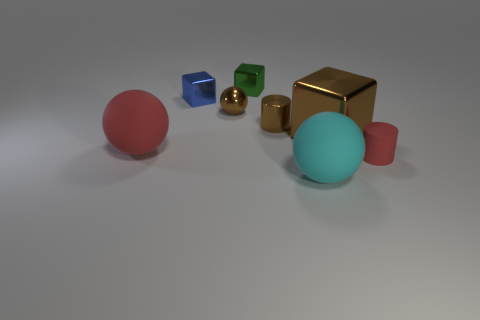The small object that is in front of the red matte sphere has what shape?
Your answer should be very brief. Cylinder. Do the green block and the blue thing have the same material?
Your answer should be very brief. Yes. Is there anything else that is made of the same material as the tiny brown cylinder?
Provide a succinct answer. Yes. There is a tiny brown thing that is the same shape as the tiny red thing; what is its material?
Provide a short and direct response. Metal. Is the number of rubber cylinders that are to the left of the small red rubber object less than the number of brown metal cylinders?
Make the answer very short. Yes. How many shiny objects are behind the shiny cylinder?
Your answer should be compact. 3. Do the big rubber thing that is in front of the tiny rubber cylinder and the rubber thing to the left of the tiny blue metallic block have the same shape?
Ensure brevity in your answer.  Yes. There is a matte thing that is left of the matte cylinder and right of the blue cube; what is its shape?
Ensure brevity in your answer.  Sphere. There is a brown block that is the same material as the small brown ball; what is its size?
Your answer should be compact. Large. Are there fewer small green shiny cubes than things?
Your answer should be very brief. Yes. 